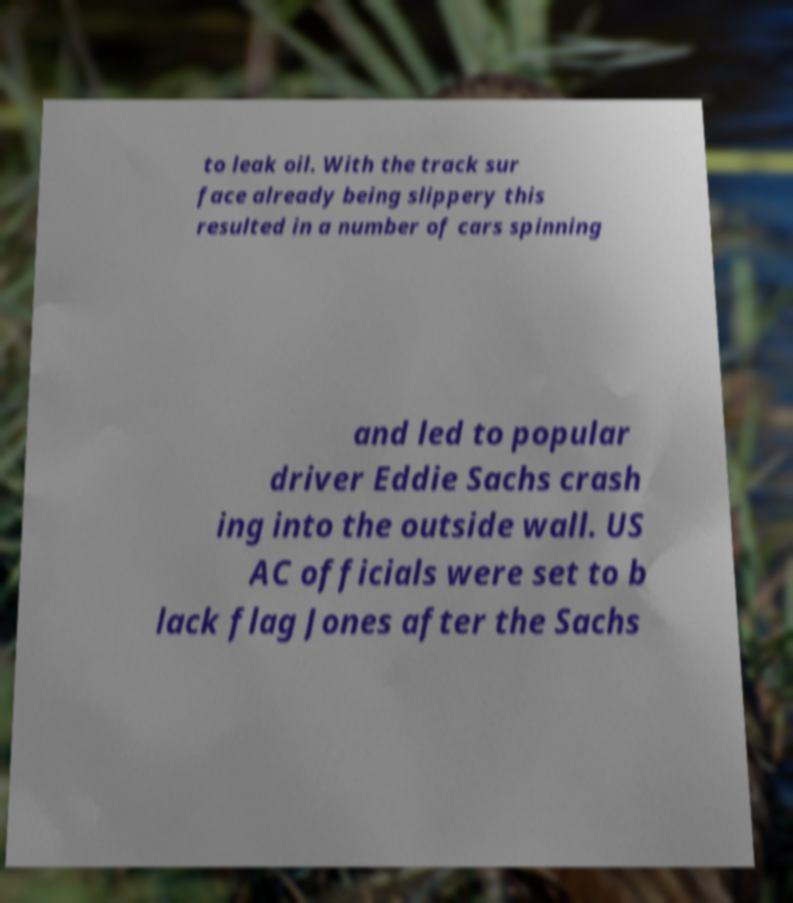Please identify and transcribe the text found in this image. to leak oil. With the track sur face already being slippery this resulted in a number of cars spinning and led to popular driver Eddie Sachs crash ing into the outside wall. US AC officials were set to b lack flag Jones after the Sachs 